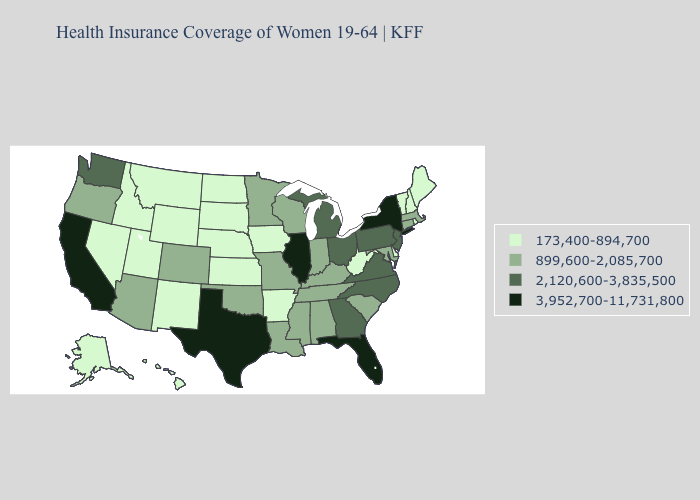Name the states that have a value in the range 3,952,700-11,731,800?
Answer briefly. California, Florida, Illinois, New York, Texas. Among the states that border Colorado , which have the highest value?
Give a very brief answer. Arizona, Oklahoma. Does Wisconsin have a higher value than Michigan?
Write a very short answer. No. Which states have the lowest value in the Northeast?
Concise answer only. Maine, New Hampshire, Rhode Island, Vermont. What is the value of Kansas?
Answer briefly. 173,400-894,700. Does Maine have the same value as Oregon?
Concise answer only. No. Does Rhode Island have a lower value than Delaware?
Quick response, please. No. What is the lowest value in the USA?
Keep it brief. 173,400-894,700. Name the states that have a value in the range 2,120,600-3,835,500?
Write a very short answer. Georgia, Michigan, New Jersey, North Carolina, Ohio, Pennsylvania, Virginia, Washington. What is the value of Vermont?
Keep it brief. 173,400-894,700. What is the highest value in states that border North Dakota?
Quick response, please. 899,600-2,085,700. Name the states that have a value in the range 2,120,600-3,835,500?
Be succinct. Georgia, Michigan, New Jersey, North Carolina, Ohio, Pennsylvania, Virginia, Washington. What is the highest value in the USA?
Quick response, please. 3,952,700-11,731,800. Which states have the lowest value in the MidWest?
Give a very brief answer. Iowa, Kansas, Nebraska, North Dakota, South Dakota. Name the states that have a value in the range 173,400-894,700?
Short answer required. Alaska, Arkansas, Delaware, Hawaii, Idaho, Iowa, Kansas, Maine, Montana, Nebraska, Nevada, New Hampshire, New Mexico, North Dakota, Rhode Island, South Dakota, Utah, Vermont, West Virginia, Wyoming. 